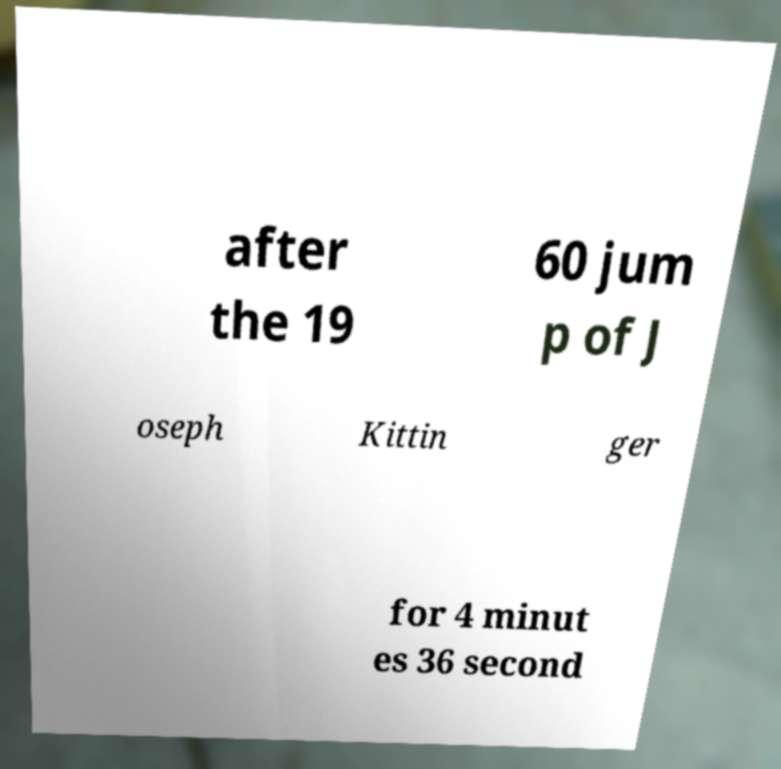Could you extract and type out the text from this image? after the 19 60 jum p of J oseph Kittin ger for 4 minut es 36 second 